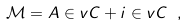<formula> <loc_0><loc_0><loc_500><loc_500>\mathcal { M } = A \in v { C } + i \in v { C } \ ,</formula> 